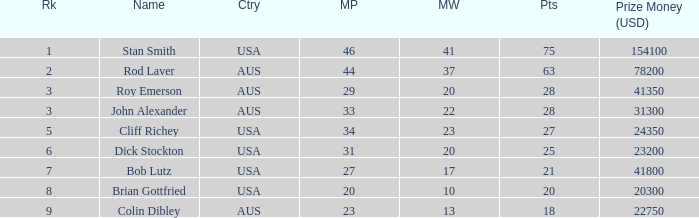How many matches did colin dibley win 13.0. 